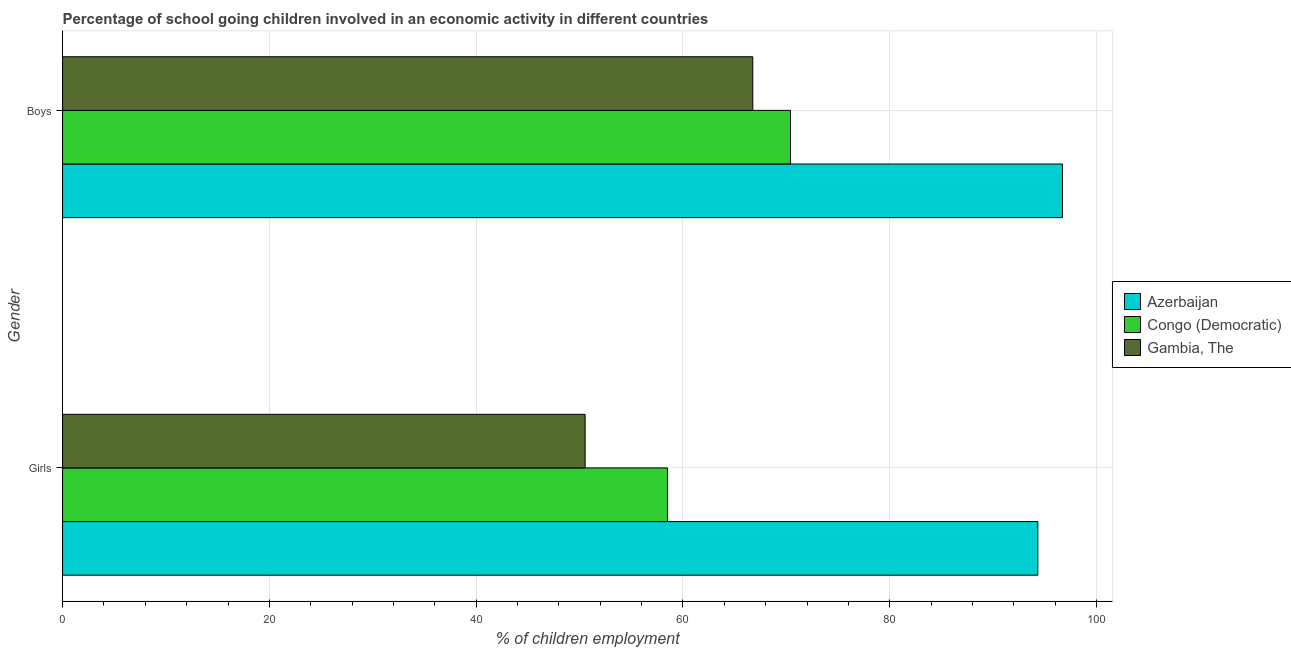How many groups of bars are there?
Offer a very short reply. 2. Are the number of bars on each tick of the Y-axis equal?
Provide a short and direct response. Yes. How many bars are there on the 2nd tick from the bottom?
Offer a very short reply. 3. What is the label of the 2nd group of bars from the top?
Keep it short and to the point. Girls. What is the percentage of school going girls in Gambia, The?
Your answer should be very brief. 50.54. Across all countries, what is the maximum percentage of school going girls?
Make the answer very short. 94.32. Across all countries, what is the minimum percentage of school going girls?
Provide a succinct answer. 50.54. In which country was the percentage of school going girls maximum?
Keep it short and to the point. Azerbaijan. In which country was the percentage of school going girls minimum?
Ensure brevity in your answer.  Gambia, The. What is the total percentage of school going girls in the graph?
Keep it short and to the point. 203.36. What is the difference between the percentage of school going boys in Azerbaijan and that in Gambia, The?
Provide a succinct answer. 29.95. What is the difference between the percentage of school going boys in Gambia, The and the percentage of school going girls in Congo (Democratic)?
Give a very brief answer. 8.25. What is the average percentage of school going girls per country?
Offer a terse response. 67.79. What is the difference between the percentage of school going boys and percentage of school going girls in Congo (Democratic)?
Make the answer very short. 11.9. In how many countries, is the percentage of school going girls greater than 20 %?
Offer a terse response. 3. What is the ratio of the percentage of school going boys in Congo (Democratic) to that in Azerbaijan?
Offer a terse response. 0.73. In how many countries, is the percentage of school going boys greater than the average percentage of school going boys taken over all countries?
Offer a terse response. 1. What does the 3rd bar from the top in Boys represents?
Offer a terse response. Azerbaijan. What does the 1st bar from the bottom in Boys represents?
Ensure brevity in your answer.  Azerbaijan. Are all the bars in the graph horizontal?
Provide a short and direct response. Yes. How many countries are there in the graph?
Your answer should be compact. 3. Are the values on the major ticks of X-axis written in scientific E-notation?
Provide a short and direct response. No. Does the graph contain grids?
Your answer should be very brief. Yes. Where does the legend appear in the graph?
Offer a terse response. Center right. How many legend labels are there?
Your answer should be very brief. 3. How are the legend labels stacked?
Provide a short and direct response. Vertical. What is the title of the graph?
Make the answer very short. Percentage of school going children involved in an economic activity in different countries. Does "Guatemala" appear as one of the legend labels in the graph?
Offer a terse response. No. What is the label or title of the X-axis?
Offer a terse response. % of children employment. What is the label or title of the Y-axis?
Your response must be concise. Gender. What is the % of children employment of Azerbaijan in Girls?
Offer a very short reply. 94.32. What is the % of children employment of Congo (Democratic) in Girls?
Your answer should be very brief. 58.5. What is the % of children employment in Gambia, The in Girls?
Ensure brevity in your answer.  50.54. What is the % of children employment of Azerbaijan in Boys?
Ensure brevity in your answer.  96.7. What is the % of children employment of Congo (Democratic) in Boys?
Make the answer very short. 70.4. What is the % of children employment in Gambia, The in Boys?
Make the answer very short. 66.75. Across all Gender, what is the maximum % of children employment of Azerbaijan?
Provide a succinct answer. 96.7. Across all Gender, what is the maximum % of children employment of Congo (Democratic)?
Your answer should be compact. 70.4. Across all Gender, what is the maximum % of children employment in Gambia, The?
Offer a terse response. 66.75. Across all Gender, what is the minimum % of children employment in Azerbaijan?
Provide a short and direct response. 94.32. Across all Gender, what is the minimum % of children employment in Congo (Democratic)?
Your answer should be very brief. 58.5. Across all Gender, what is the minimum % of children employment in Gambia, The?
Your response must be concise. 50.54. What is the total % of children employment in Azerbaijan in the graph?
Offer a very short reply. 191.02. What is the total % of children employment of Congo (Democratic) in the graph?
Offer a very short reply. 128.9. What is the total % of children employment of Gambia, The in the graph?
Your response must be concise. 117.29. What is the difference between the % of children employment of Azerbaijan in Girls and that in Boys?
Your answer should be compact. -2.38. What is the difference between the % of children employment in Gambia, The in Girls and that in Boys?
Offer a very short reply. -16.21. What is the difference between the % of children employment of Azerbaijan in Girls and the % of children employment of Congo (Democratic) in Boys?
Your response must be concise. 23.92. What is the difference between the % of children employment in Azerbaijan in Girls and the % of children employment in Gambia, The in Boys?
Your response must be concise. 27.57. What is the difference between the % of children employment of Congo (Democratic) in Girls and the % of children employment of Gambia, The in Boys?
Your response must be concise. -8.25. What is the average % of children employment of Azerbaijan per Gender?
Your answer should be very brief. 95.51. What is the average % of children employment in Congo (Democratic) per Gender?
Your response must be concise. 64.45. What is the average % of children employment in Gambia, The per Gender?
Give a very brief answer. 58.64. What is the difference between the % of children employment of Azerbaijan and % of children employment of Congo (Democratic) in Girls?
Provide a succinct answer. 35.82. What is the difference between the % of children employment in Azerbaijan and % of children employment in Gambia, The in Girls?
Give a very brief answer. 43.78. What is the difference between the % of children employment in Congo (Democratic) and % of children employment in Gambia, The in Girls?
Your response must be concise. 7.96. What is the difference between the % of children employment of Azerbaijan and % of children employment of Congo (Democratic) in Boys?
Provide a succinct answer. 26.3. What is the difference between the % of children employment of Azerbaijan and % of children employment of Gambia, The in Boys?
Offer a very short reply. 29.95. What is the difference between the % of children employment of Congo (Democratic) and % of children employment of Gambia, The in Boys?
Your answer should be very brief. 3.65. What is the ratio of the % of children employment of Azerbaijan in Girls to that in Boys?
Provide a short and direct response. 0.98. What is the ratio of the % of children employment in Congo (Democratic) in Girls to that in Boys?
Ensure brevity in your answer.  0.83. What is the ratio of the % of children employment in Gambia, The in Girls to that in Boys?
Ensure brevity in your answer.  0.76. What is the difference between the highest and the second highest % of children employment in Azerbaijan?
Your response must be concise. 2.38. What is the difference between the highest and the second highest % of children employment in Congo (Democratic)?
Ensure brevity in your answer.  11.9. What is the difference between the highest and the second highest % of children employment in Gambia, The?
Your response must be concise. 16.21. What is the difference between the highest and the lowest % of children employment of Azerbaijan?
Ensure brevity in your answer.  2.38. What is the difference between the highest and the lowest % of children employment in Gambia, The?
Provide a succinct answer. 16.21. 